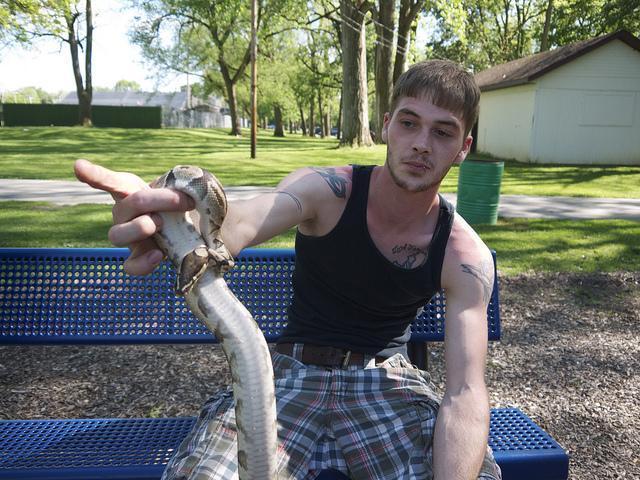How many benches can you see?
Give a very brief answer. 1. How many red fish kites are there?
Give a very brief answer. 0. 